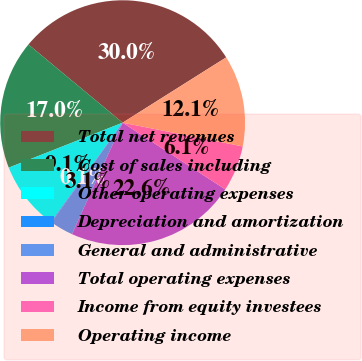Convert chart to OTSL. <chart><loc_0><loc_0><loc_500><loc_500><pie_chart><fcel>Total net revenues<fcel>Cost of sales including<fcel>Other operating expenses<fcel>Depreciation and amortization<fcel>General and administrative<fcel>Total operating expenses<fcel>Income from equity investees<fcel>Operating income<nl><fcel>30.02%<fcel>17.01%<fcel>9.06%<fcel>0.08%<fcel>3.08%<fcel>22.62%<fcel>6.07%<fcel>12.06%<nl></chart> 